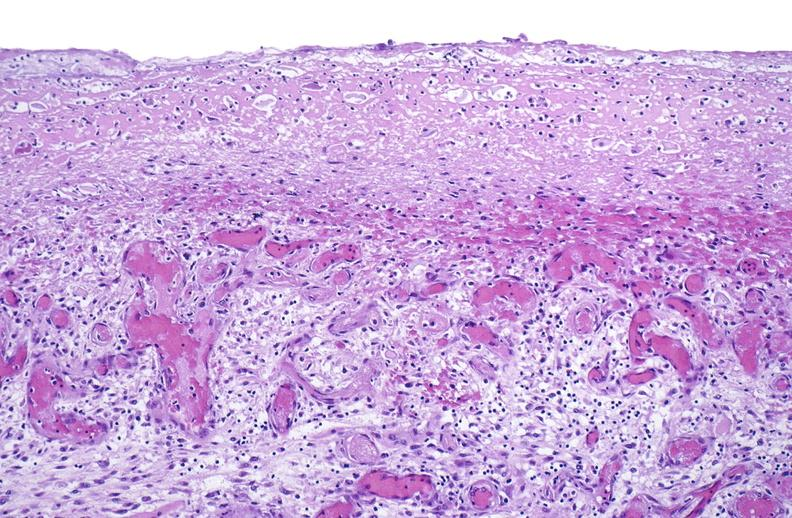what is present?
Answer the question using a single word or phrase. Soft tissue 